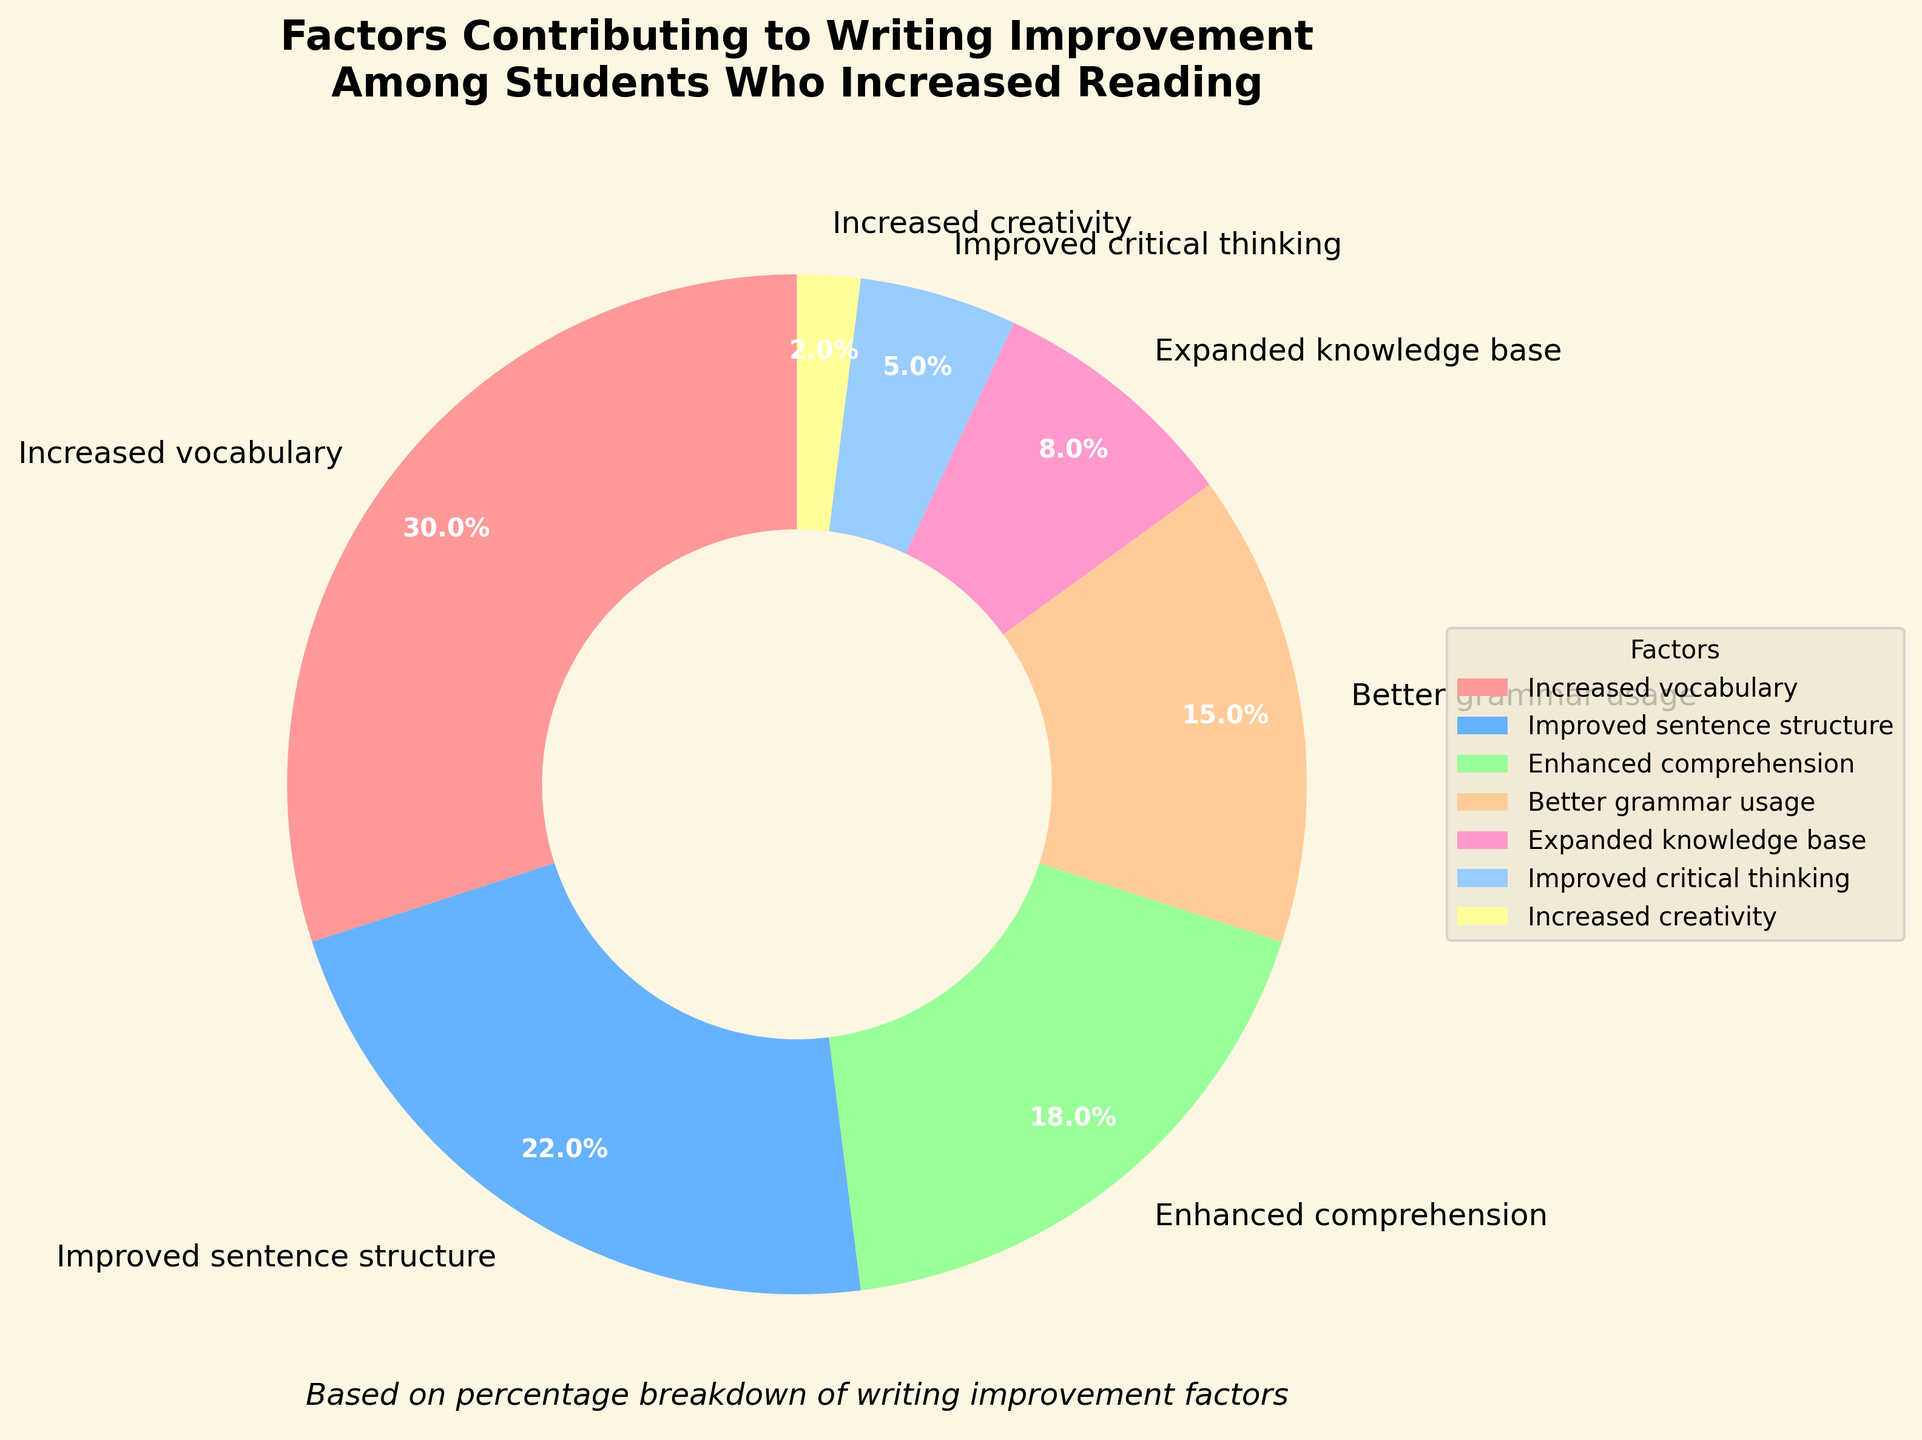What is the largest factor contributing to writing improvement? The segment representing "Increased vocabulary" is the largest in the pie chart, occupying 30% of the entire pie. Therefore, "Increased vocabulary" is the largest factor contributing to writing improvement among students who increased their reading.
Answer: Increased vocabulary What is the combined percentage for "Improved sentence structure" and "Better grammar usage"? To find the combined percentage, we add the individual percentages of "Improved sentence structure" and "Better grammar usage". The percentages are 22% and 15% respectively. 22% + 15% = 37%.
Answer: 37% Which factor contributes the least to writing improvement? The segment with the smallest area represents "Increased creativity", which accounts for 2% of the pie chart. This makes "Increased creativity" the factor contributing the least to writing improvement.
Answer: Increased creativity Is the percentage for "Enhanced comprehension" greater than "Expanded knowledge base"? By examining the pie chart, we see that "Enhanced comprehension" accounts for 18%, while "Expanded knowledge base" accounts for only 8%. Thus, the percentage for "Enhanced comprehension" is indeed greater than that for "Expanded knowledge base".
Answer: Yes Arrange the factors contributing to writing improvement from largest to smallest. The factors and their respective percentages are: Increased vocabulary (30%), Improved sentence structure (22%), Enhanced comprehension (18%), Better grammar usage (15%), Expanded knowledge base (8%), Improved critical thinking (5%), and Increased creativity (2%). Arranging them in descending order gives us: Increased vocabulary, Improved sentence structure, Enhanced comprehension, Better grammar usage, Expanded knowledge base, Improved critical thinking, Increased creativity.
Answer: Increased vocabulary, Improved sentence structure, Enhanced comprehension, Better grammar usage, Expanded knowledge base, Improved critical thinking, Increased creativity What is the sum of the percentages for the four smallest factors? To find the combined percentage for the four smallest factors, we sum the percentages of "Expanded knowledge base" (8%), "Improved critical thinking" (5%), and "Increased creativity" (2%). 8% + 5% + 2% = 15%.
Answer: 15% What color represents "Improved sentence structure" in the chart? The pie chart uses specific colors for each factor. "Improved sentence structure" is represented by the second segment, which is blue.
Answer: Blue 